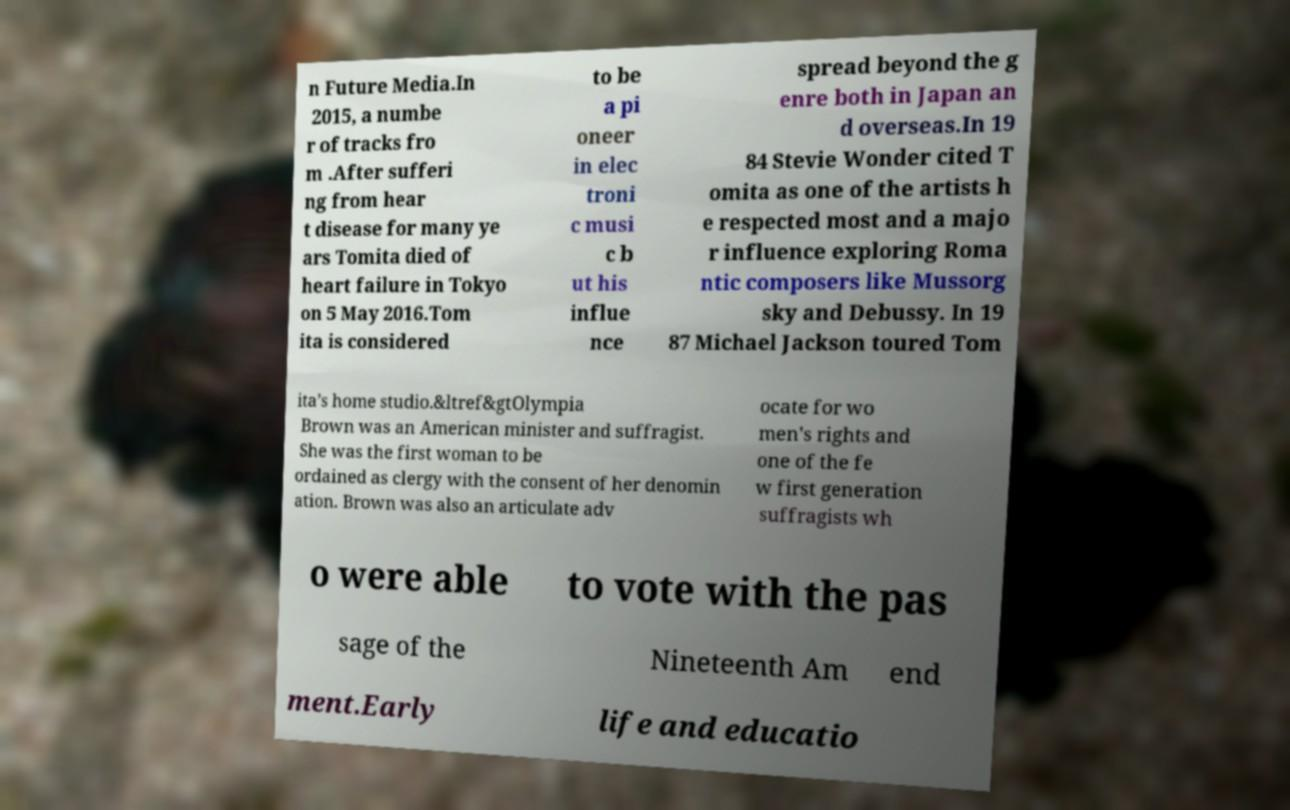Can you accurately transcribe the text from the provided image for me? n Future Media.In 2015, a numbe r of tracks fro m .After sufferi ng from hear t disease for many ye ars Tomita died of heart failure in Tokyo on 5 May 2016.Tom ita is considered to be a pi oneer in elec troni c musi c b ut his influe nce spread beyond the g enre both in Japan an d overseas.In 19 84 Stevie Wonder cited T omita as one of the artists h e respected most and a majo r influence exploring Roma ntic composers like Mussorg sky and Debussy. In 19 87 Michael Jackson toured Tom ita’s home studio.&ltref&gtOlympia Brown was an American minister and suffragist. She was the first woman to be ordained as clergy with the consent of her denomin ation. Brown was also an articulate adv ocate for wo men's rights and one of the fe w first generation suffragists wh o were able to vote with the pas sage of the Nineteenth Am end ment.Early life and educatio 